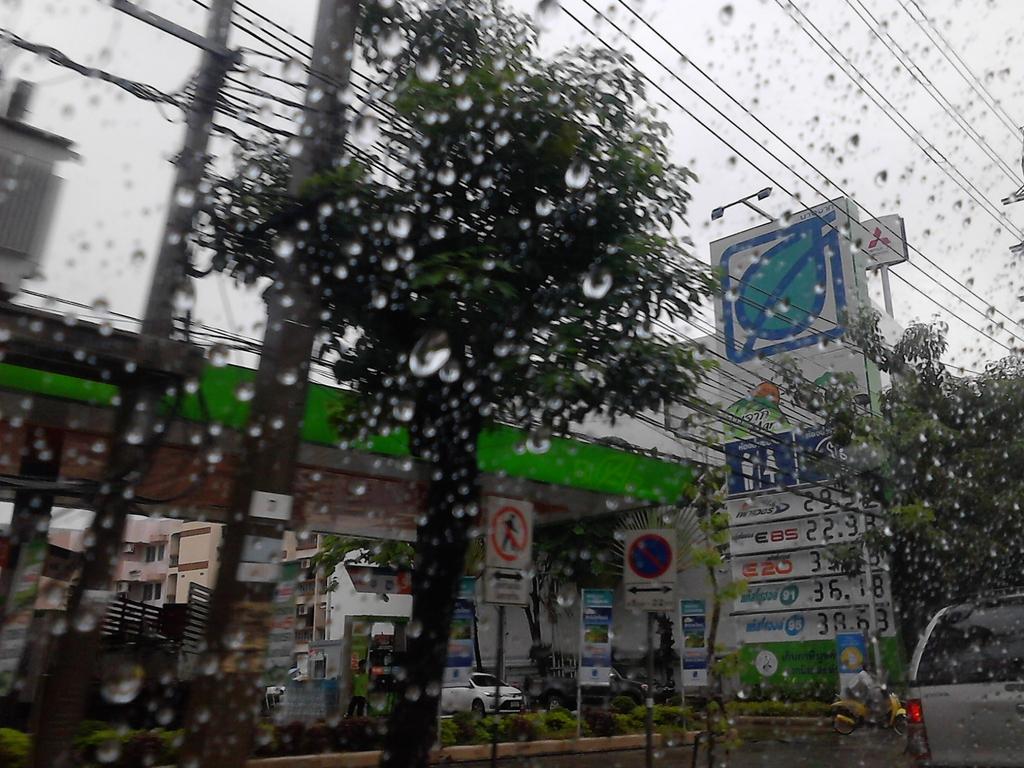In one or two sentences, can you explain what this image depicts? Front portion of the image we can see water droplets, trees, poles, cables and vehicles. Background portion of the image we can see open-shed, buildings, signboards, bushes, people, light pole, board, sky and things.   